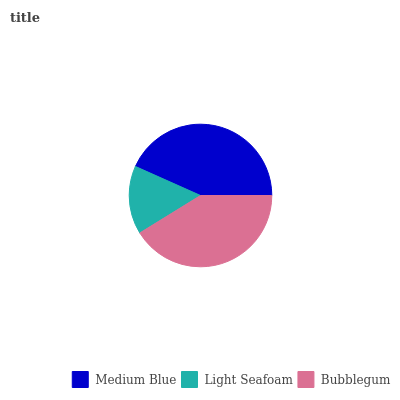Is Light Seafoam the minimum?
Answer yes or no. Yes. Is Medium Blue the maximum?
Answer yes or no. Yes. Is Bubblegum the minimum?
Answer yes or no. No. Is Bubblegum the maximum?
Answer yes or no. No. Is Bubblegum greater than Light Seafoam?
Answer yes or no. Yes. Is Light Seafoam less than Bubblegum?
Answer yes or no. Yes. Is Light Seafoam greater than Bubblegum?
Answer yes or no. No. Is Bubblegum less than Light Seafoam?
Answer yes or no. No. Is Bubblegum the high median?
Answer yes or no. Yes. Is Bubblegum the low median?
Answer yes or no. Yes. Is Light Seafoam the high median?
Answer yes or no. No. Is Light Seafoam the low median?
Answer yes or no. No. 